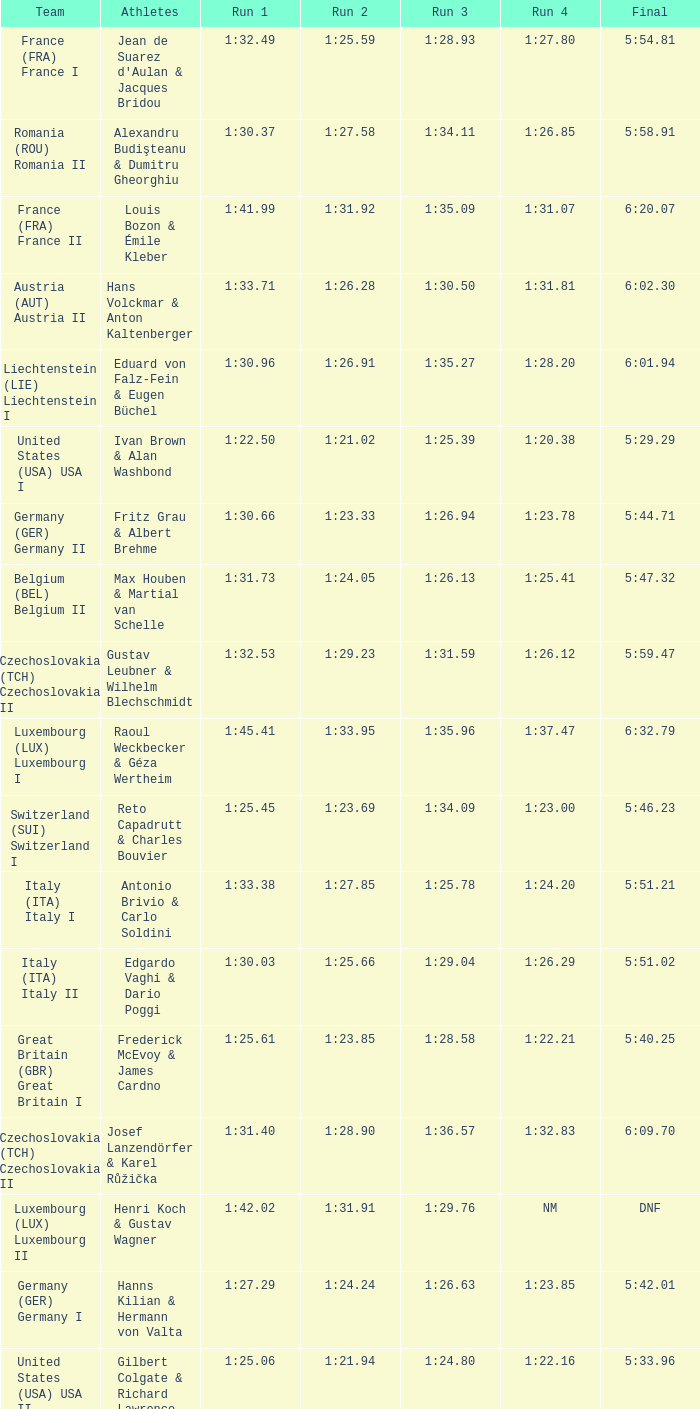Which Run 4 has a Run 1 of 1:25.82? 1:23.80. 